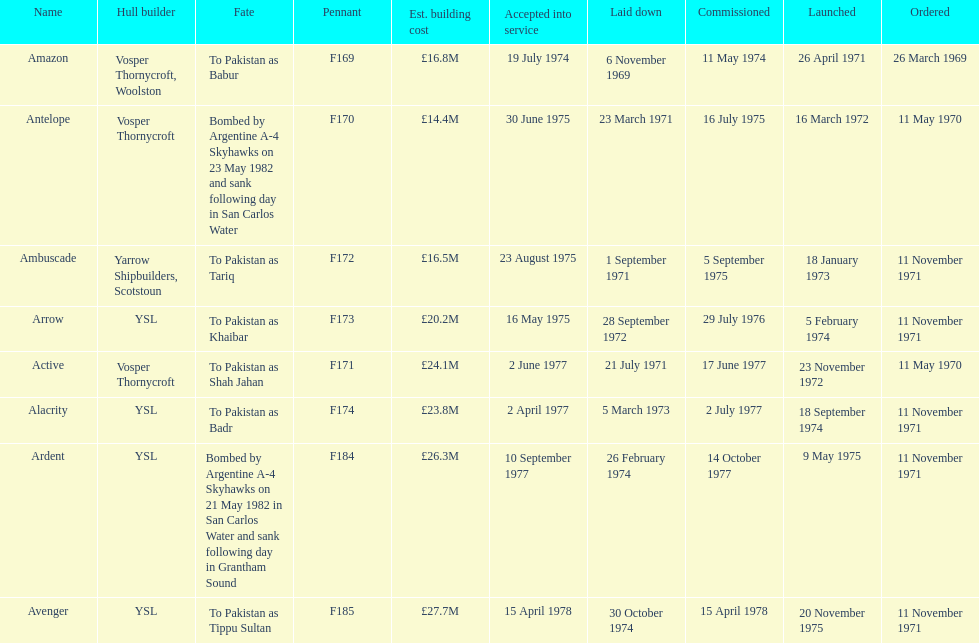Tell me the number of ships that went to pakistan. 6. 